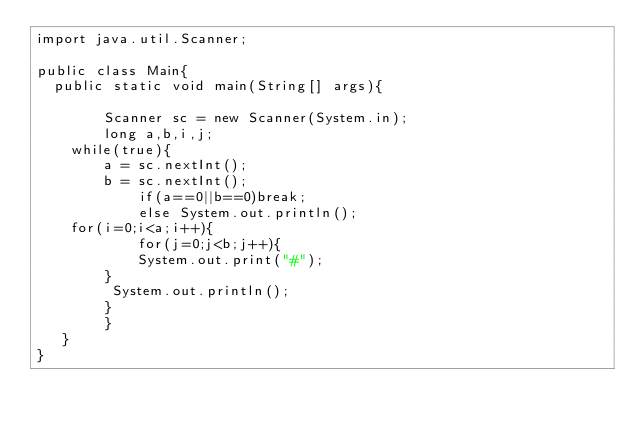<code> <loc_0><loc_0><loc_500><loc_500><_Java_>import java.util.Scanner;

public class Main{
	public static void main(String[] args){
        
        Scanner sc = new Scanner(System.in);
        long a,b,i,j;
		while(true){
        a = sc.nextInt();
        b = sc.nextInt();
            if(a==0||b==0)break;
            else System.out.println();
		for(i=0;i<a;i++){
            for(j=0;j<b;j++){
            System.out.print("#");
        } 
         System.out.println(); 
        }
        }
   }
}
</code> 